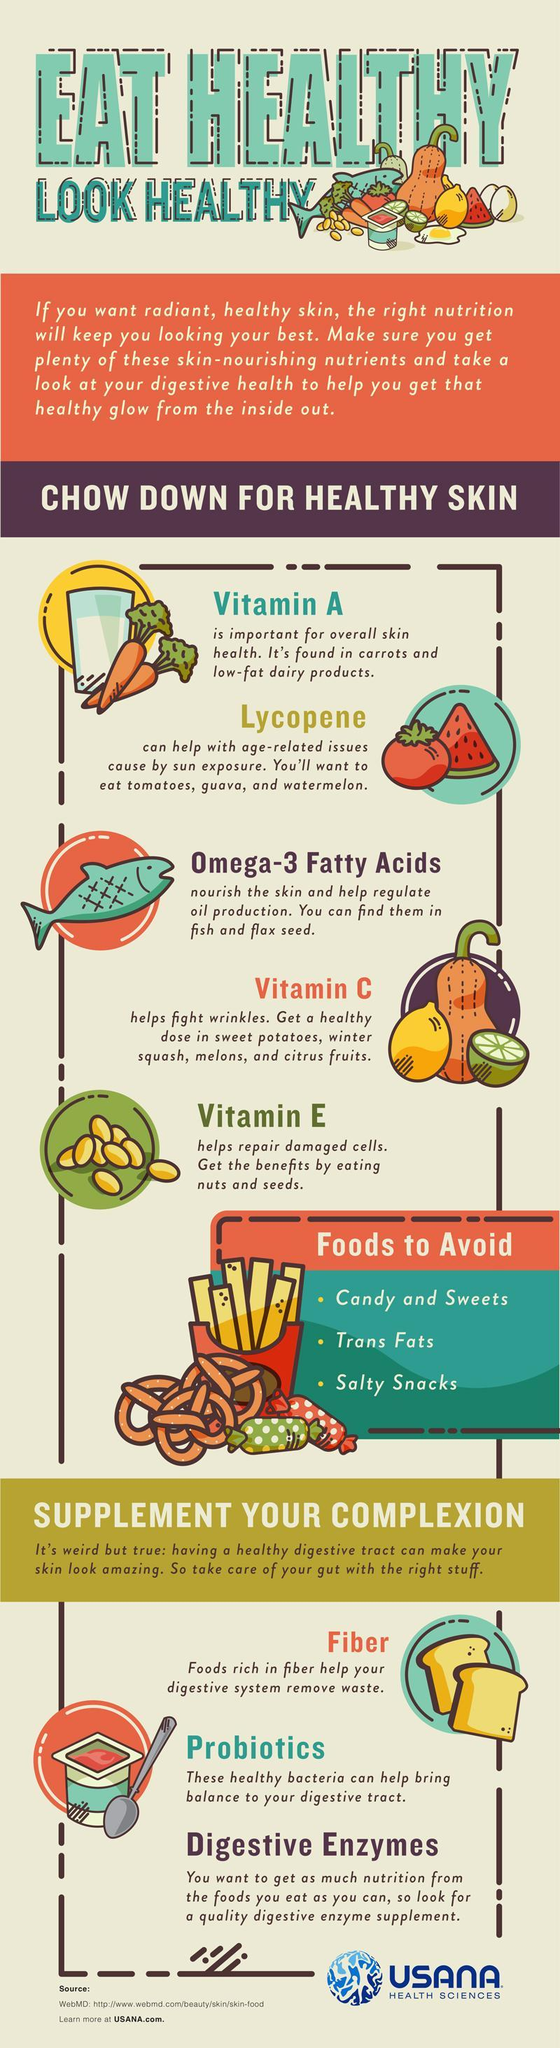Which are Vitamins essential for a healthy skin?
Answer the question with a short phrase. Vitamin A, Vitamin C, Vitamin E 